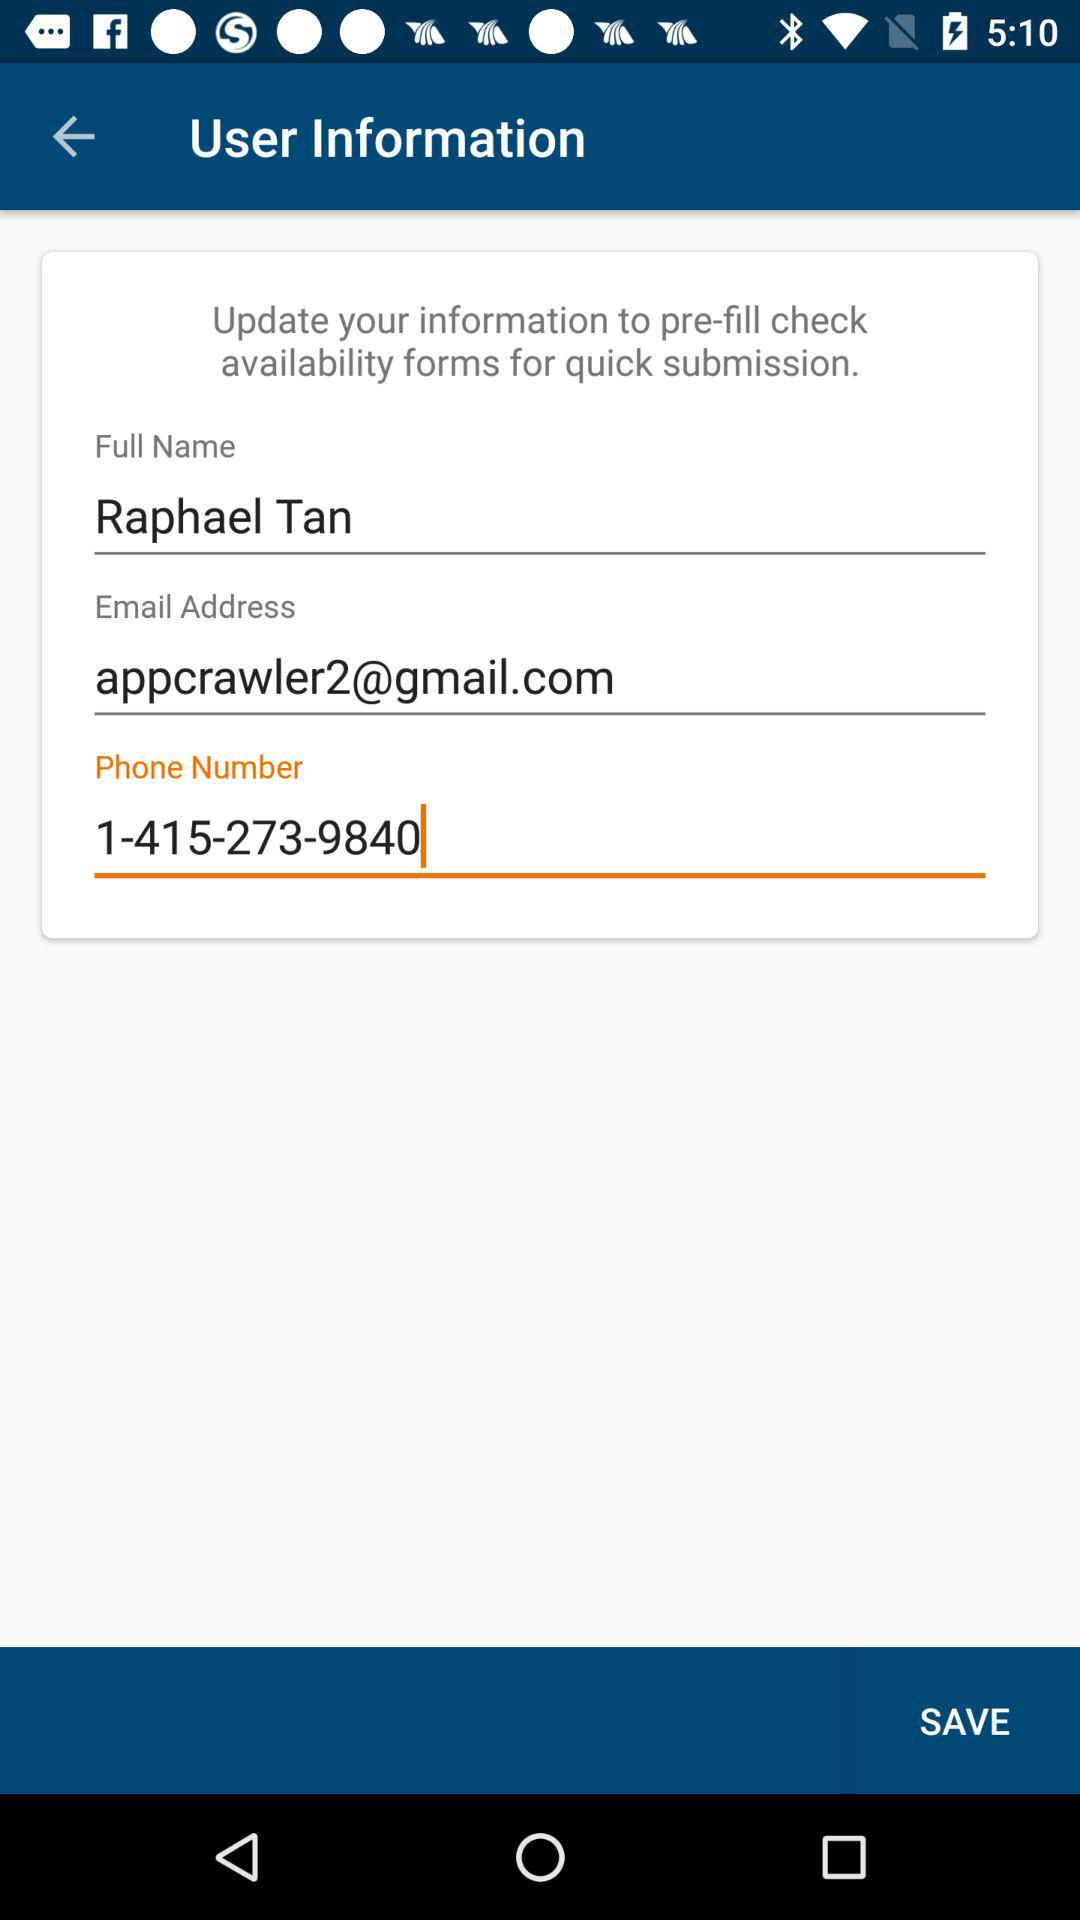What is the phone number? The phone number is 1-415-273-9840. 